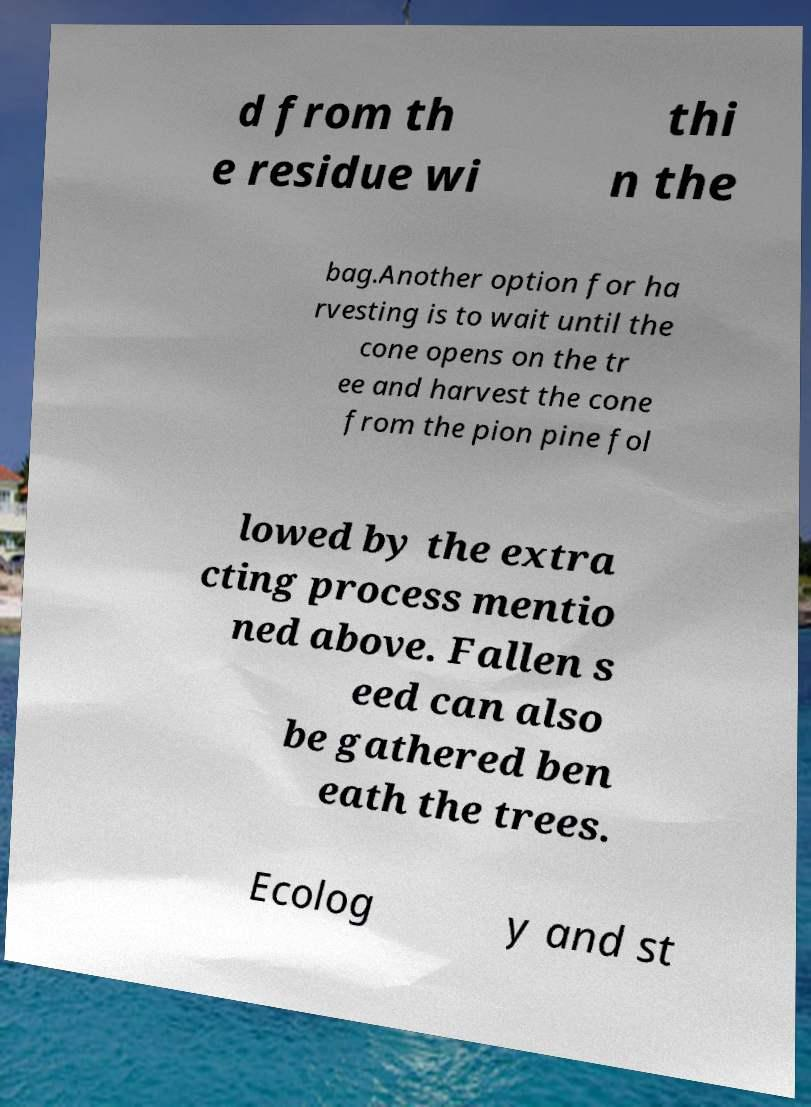Can you accurately transcribe the text from the provided image for me? d from th e residue wi thi n the bag.Another option for ha rvesting is to wait until the cone opens on the tr ee and harvest the cone from the pion pine fol lowed by the extra cting process mentio ned above. Fallen s eed can also be gathered ben eath the trees. Ecolog y and st 